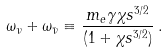Convert formula to latex. <formula><loc_0><loc_0><loc_500><loc_500>\omega _ { \nu } + \omega _ { \bar { \nu } } \equiv \frac { m _ { e } \gamma \chi s ^ { 3 / 2 } } { ( 1 + \chi s ^ { 3 / 2 } ) } \, .</formula> 